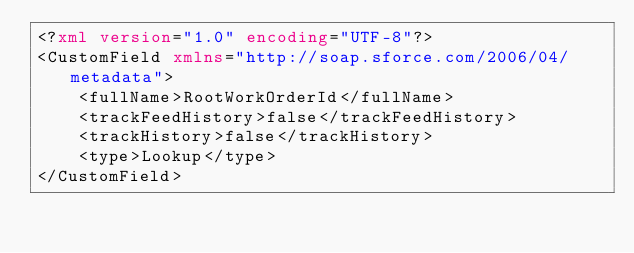Convert code to text. <code><loc_0><loc_0><loc_500><loc_500><_XML_><?xml version="1.0" encoding="UTF-8"?>
<CustomField xmlns="http://soap.sforce.com/2006/04/metadata">
    <fullName>RootWorkOrderId</fullName>
    <trackFeedHistory>false</trackFeedHistory>
    <trackHistory>false</trackHistory>
    <type>Lookup</type>
</CustomField>
</code> 